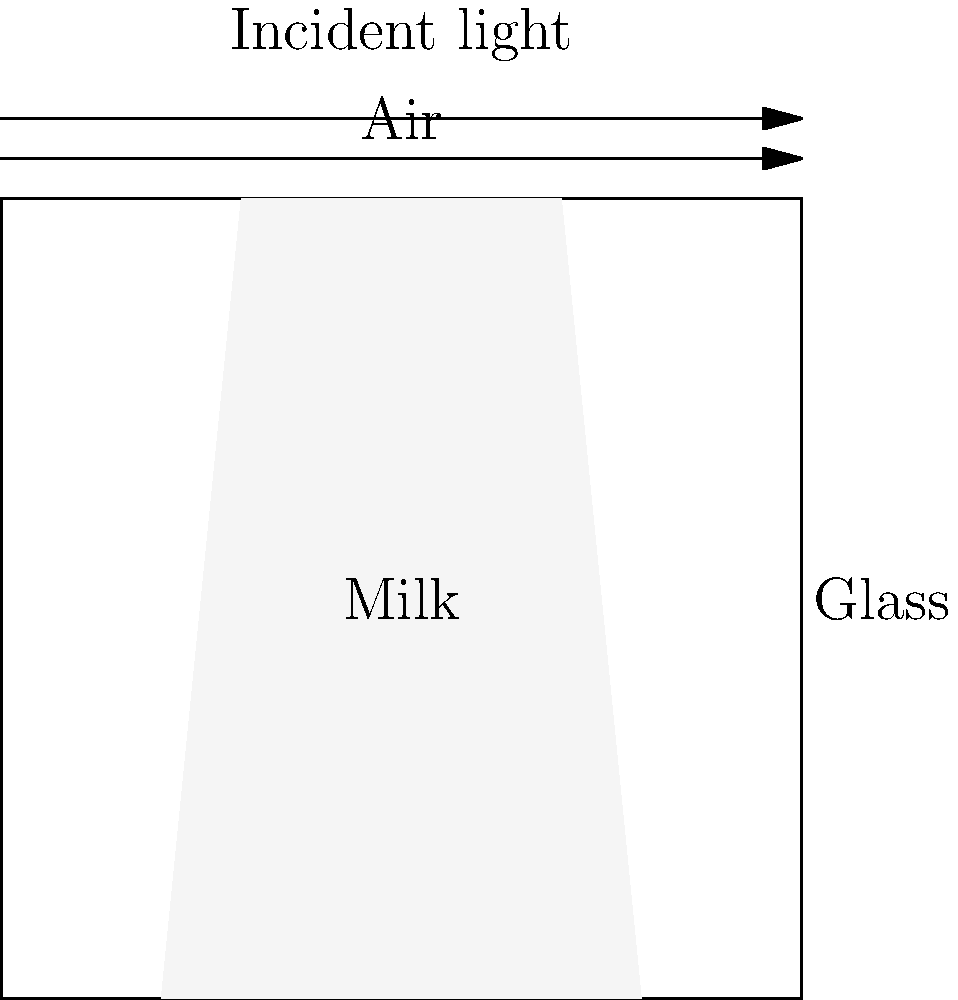In a rustic farmhouse kitchen, a glass of fresh milk sits on a wooden table, illuminated by sunlight streaming through the window. As an actor preparing for a role as a rural physicist, you're fascinated by the way light interacts with the milk. If the refractive index of air is 1.00, the refractive index of glass is 1.50, and the refractive index of milk is 1.35, calculate the angle of refraction when light enters the milk from air at an angle of incidence of 30°. Assume the glass is very thin and its effect on refraction is negligible. To solve this problem, we'll use Snell's Law, which describes how light refracts when passing from one medium to another. The steps are as follows:

1) Snell's Law states: $n_1 \sin(\theta_1) = n_2 \sin(\theta_2)$

   Where:
   $n_1$ is the refractive index of the first medium (air)
   $n_2$ is the refractive index of the second medium (milk)
   $\theta_1$ is the angle of incidence
   $\theta_2$ is the angle of refraction

2) We're given:
   $n_1 = 1.00$ (air)
   $n_2 = 1.35$ (milk)
   $\theta_1 = 30°$

3) Let's substitute these values into Snell's Law:

   $1.00 \sin(30°) = 1.35 \sin(\theta_2)$

4) Simplify the left side:
   $0.5 = 1.35 \sin(\theta_2)$

5) Solve for $\sin(\theta_2)$:
   $\sin(\theta_2) = \frac{0.5}{1.35} \approx 0.3704$

6) To find $\theta_2$, we need to take the inverse sine (arcsin) of both sides:
   $\theta_2 = \arcsin(0.3704)$

7) Calculate the result:
   $\theta_2 \approx 21.7°$

Therefore, the angle of refraction when light enters the milk from air at a 30° angle of incidence is approximately 21.7°.
Answer: 21.7° 